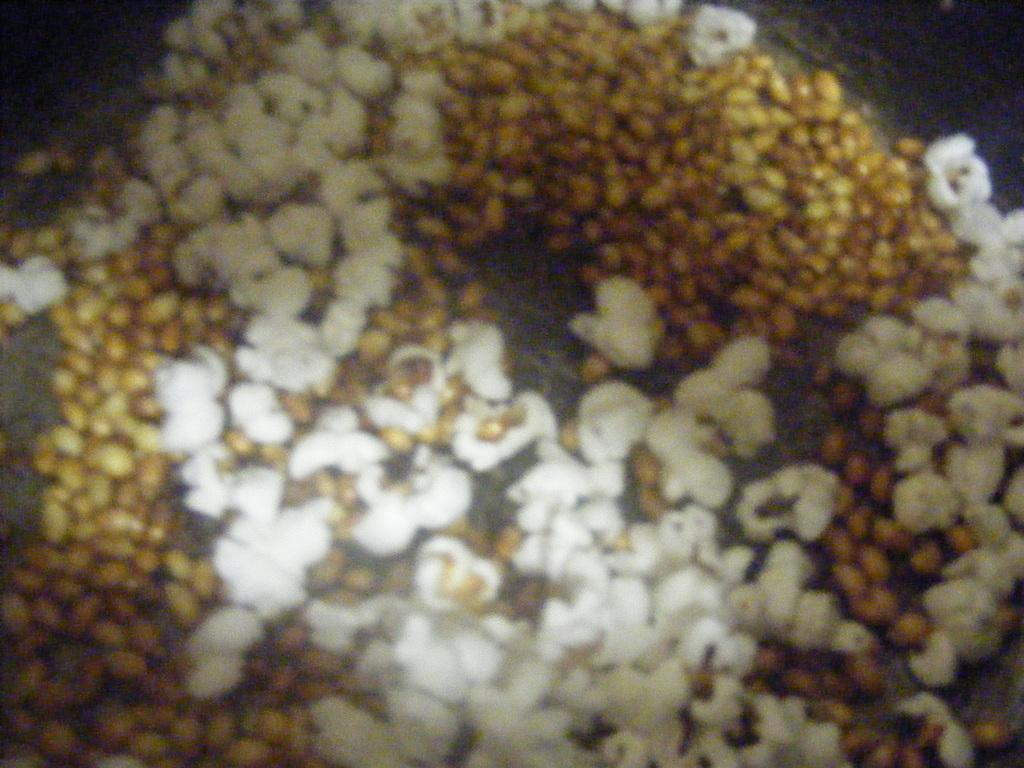What is in the bowl that is visible in the image? The bowl contains popcorns. Can you describe the contents of the bowl in more detail? The bowl contains popcorns, which are a popular snack typically enjoyed during movie nights or other events. What type of shoes can be seen in the image? There are no shoes present in the image; it only features a bowl of popcorns. What historical event is depicted in the image? There is no historical event depicted in the image; it only features a bowl of popcorns. 